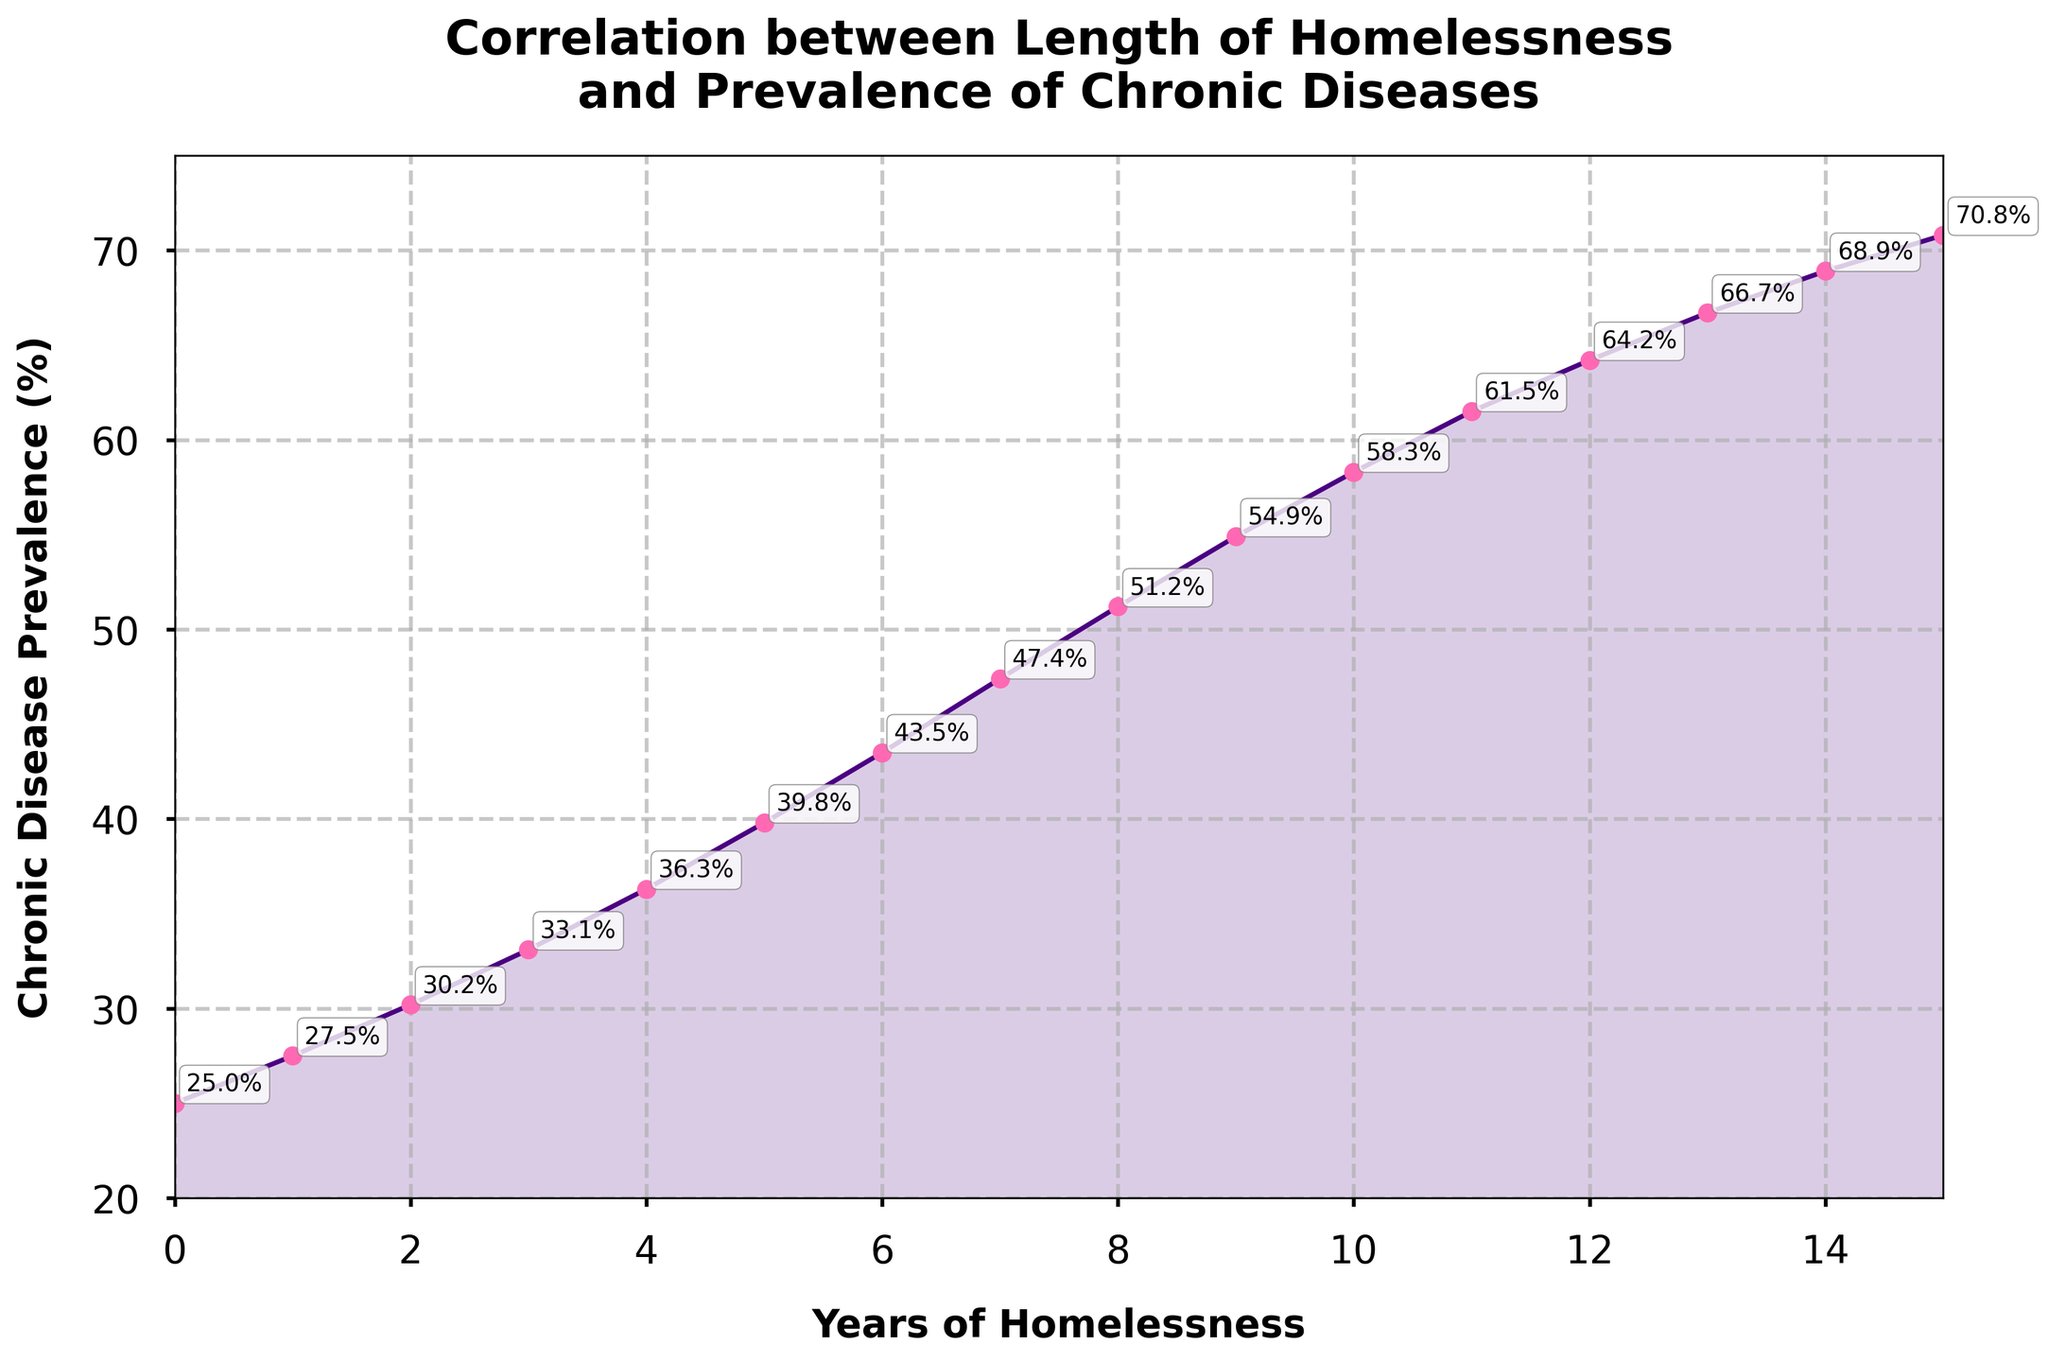How has the chronic disease prevalence rate changed from year 0 to year 15? To determine the change in chronic disease prevalence, we need to compare the values at year 0 and year 15. At year 0, the prevalence is 25.0%, and at year 15, it is 70.8%. The change is 70.8% - 25.0% = 45.8%.
Answer: 45.8% At what year does the chronic disease prevalence first exceed 50%? To find the year when the chronic disease prevalence first exceeds 50%, we need to look at the data points and see that it happens between years 7 and 8. At year 8, the prevalence is 51.2%, which is the first value above 50%.
Answer: Year 8 By how much does the chronic disease prevalence increase from year 5 to year 10? At year 5, the prevalence is 39.8%, and at year 10, it is 58.3%. The increase is calculated as 58.3% - 39.8% = 18.5%.
Answer: 18.5% What is the average chronic disease prevalence over the 15-year period? To calculate the average, sum all yearly prevalence values and then divide by the number of years (16, including year 0). The sum is 729.8%. So, 729.8% / 16 = 45.6125%.
Answer: 45.61% Which year shows the steepest increase in chronic disease prevalence? To determine the steepest increase, we find the year with the largest difference in prevalence from the previous year. The largest difference is between year 11 (61.5%) and year 12 (64.2%), which is an increase of 2.7%.
Answer: Year 11-12 What is the ratio of chronic disease prevalence at year 15 to year 5? The prevalence at year 15 is 70.8%, and at year 5 it is 39.8%. The ratio is calculated as 70.8% / 39.8% ≈ 1.78.
Answer: 1.78 Compare the chronic disease prevalence between the first 5 years and the last 5 years. First, calculate the average for the first 5 years (25.0+27.5+30.2+33.1+36.3) / 5 = 30.42%. For the last 5 years, the average is (61.5+64.2+66.7+68.9+70.8) / 5 = 66.42%.
Answer: First 5 years: 30.42%, Last 5 years: 66.42% What is the prevalences' cumulative increase from year 0 to year 5? Sum the yearly increases: (27.5-25) + (30.2-27.5) + (33.1-30.2) + (36.3-33.1) + (39.8-36.3) = 2.5 + 2.7 + 2.9 + 3.2 + 3.5 = 14.8%.
Answer: 14.8% Identify the overall trend in chronic disease prevalence with increasing years of homelessness. Observing the plot, as years of homelessness increase, the chronic disease prevalence consistently rises, indicating a positive correlation.
Answer: Positive correlation 